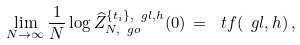Convert formula to latex. <formula><loc_0><loc_0><loc_500><loc_500>\lim _ { N \to \infty } \frac { 1 } { N } \log \widehat { Z } _ { N , \ g o } ^ { \{ t _ { i } \} , \ g l , h } ( 0 ) \, = \, \ t f ( \ g l , h ) \, ,</formula> 